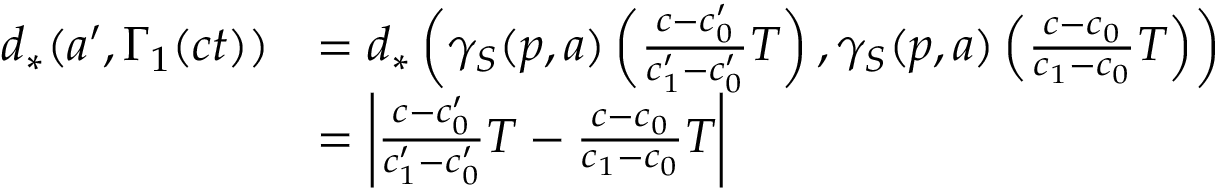Convert formula to latex. <formula><loc_0><loc_0><loc_500><loc_500>\begin{array} { r l } { d _ { * } ( a ^ { \prime } , \Gamma _ { 1 } ( c t ) ) } & { = d _ { * } \left ( \gamma _ { S } ( p , a ) \left ( \frac { c - c _ { 0 } ^ { \prime } } { c _ { 1 } ^ { \prime } - c _ { 0 } ^ { \prime } } T \right ) , \gamma _ { S } ( p , a ) \left ( \frac { c - c _ { 0 } } { c _ { 1 } - c _ { 0 } } T \right ) \right ) } \\ & { = \left | \frac { c - c _ { 0 } ^ { \prime } } { c _ { 1 } ^ { \prime } - c _ { 0 } ^ { \prime } } T - \frac { c - c _ { 0 } } { c _ { 1 } - c _ { 0 } } T \right | } \end{array}</formula> 